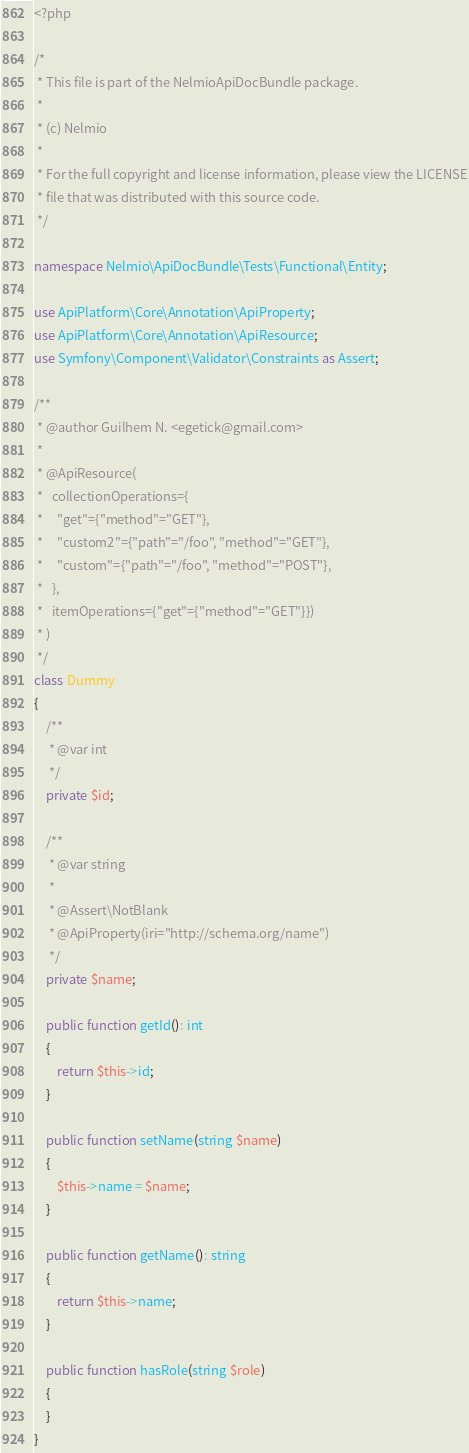<code> <loc_0><loc_0><loc_500><loc_500><_PHP_><?php

/*
 * This file is part of the NelmioApiDocBundle package.
 *
 * (c) Nelmio
 *
 * For the full copyright and license information, please view the LICENSE
 * file that was distributed with this source code.
 */

namespace Nelmio\ApiDocBundle\Tests\Functional\Entity;

use ApiPlatform\Core\Annotation\ApiProperty;
use ApiPlatform\Core\Annotation\ApiResource;
use Symfony\Component\Validator\Constraints as Assert;

/**
 * @author Guilhem N. <egetick@gmail.com>
 *
 * @ApiResource(
 *   collectionOperations={
 *     "get"={"method"="GET"},
 *     "custom2"={"path"="/foo", "method"="GET"},
 *     "custom"={"path"="/foo", "method"="POST"},
 *   },
 *   itemOperations={"get"={"method"="GET"}})
 * )
 */
class Dummy
{
    /**
     * @var int
     */
    private $id;

    /**
     * @var string
     *
     * @Assert\NotBlank
     * @ApiProperty(iri="http://schema.org/name")
     */
    private $name;

    public function getId(): int
    {
        return $this->id;
    }

    public function setName(string $name)
    {
        $this->name = $name;
    }

    public function getName(): string
    {
        return $this->name;
    }

    public function hasRole(string $role)
    {
    }
}
</code> 